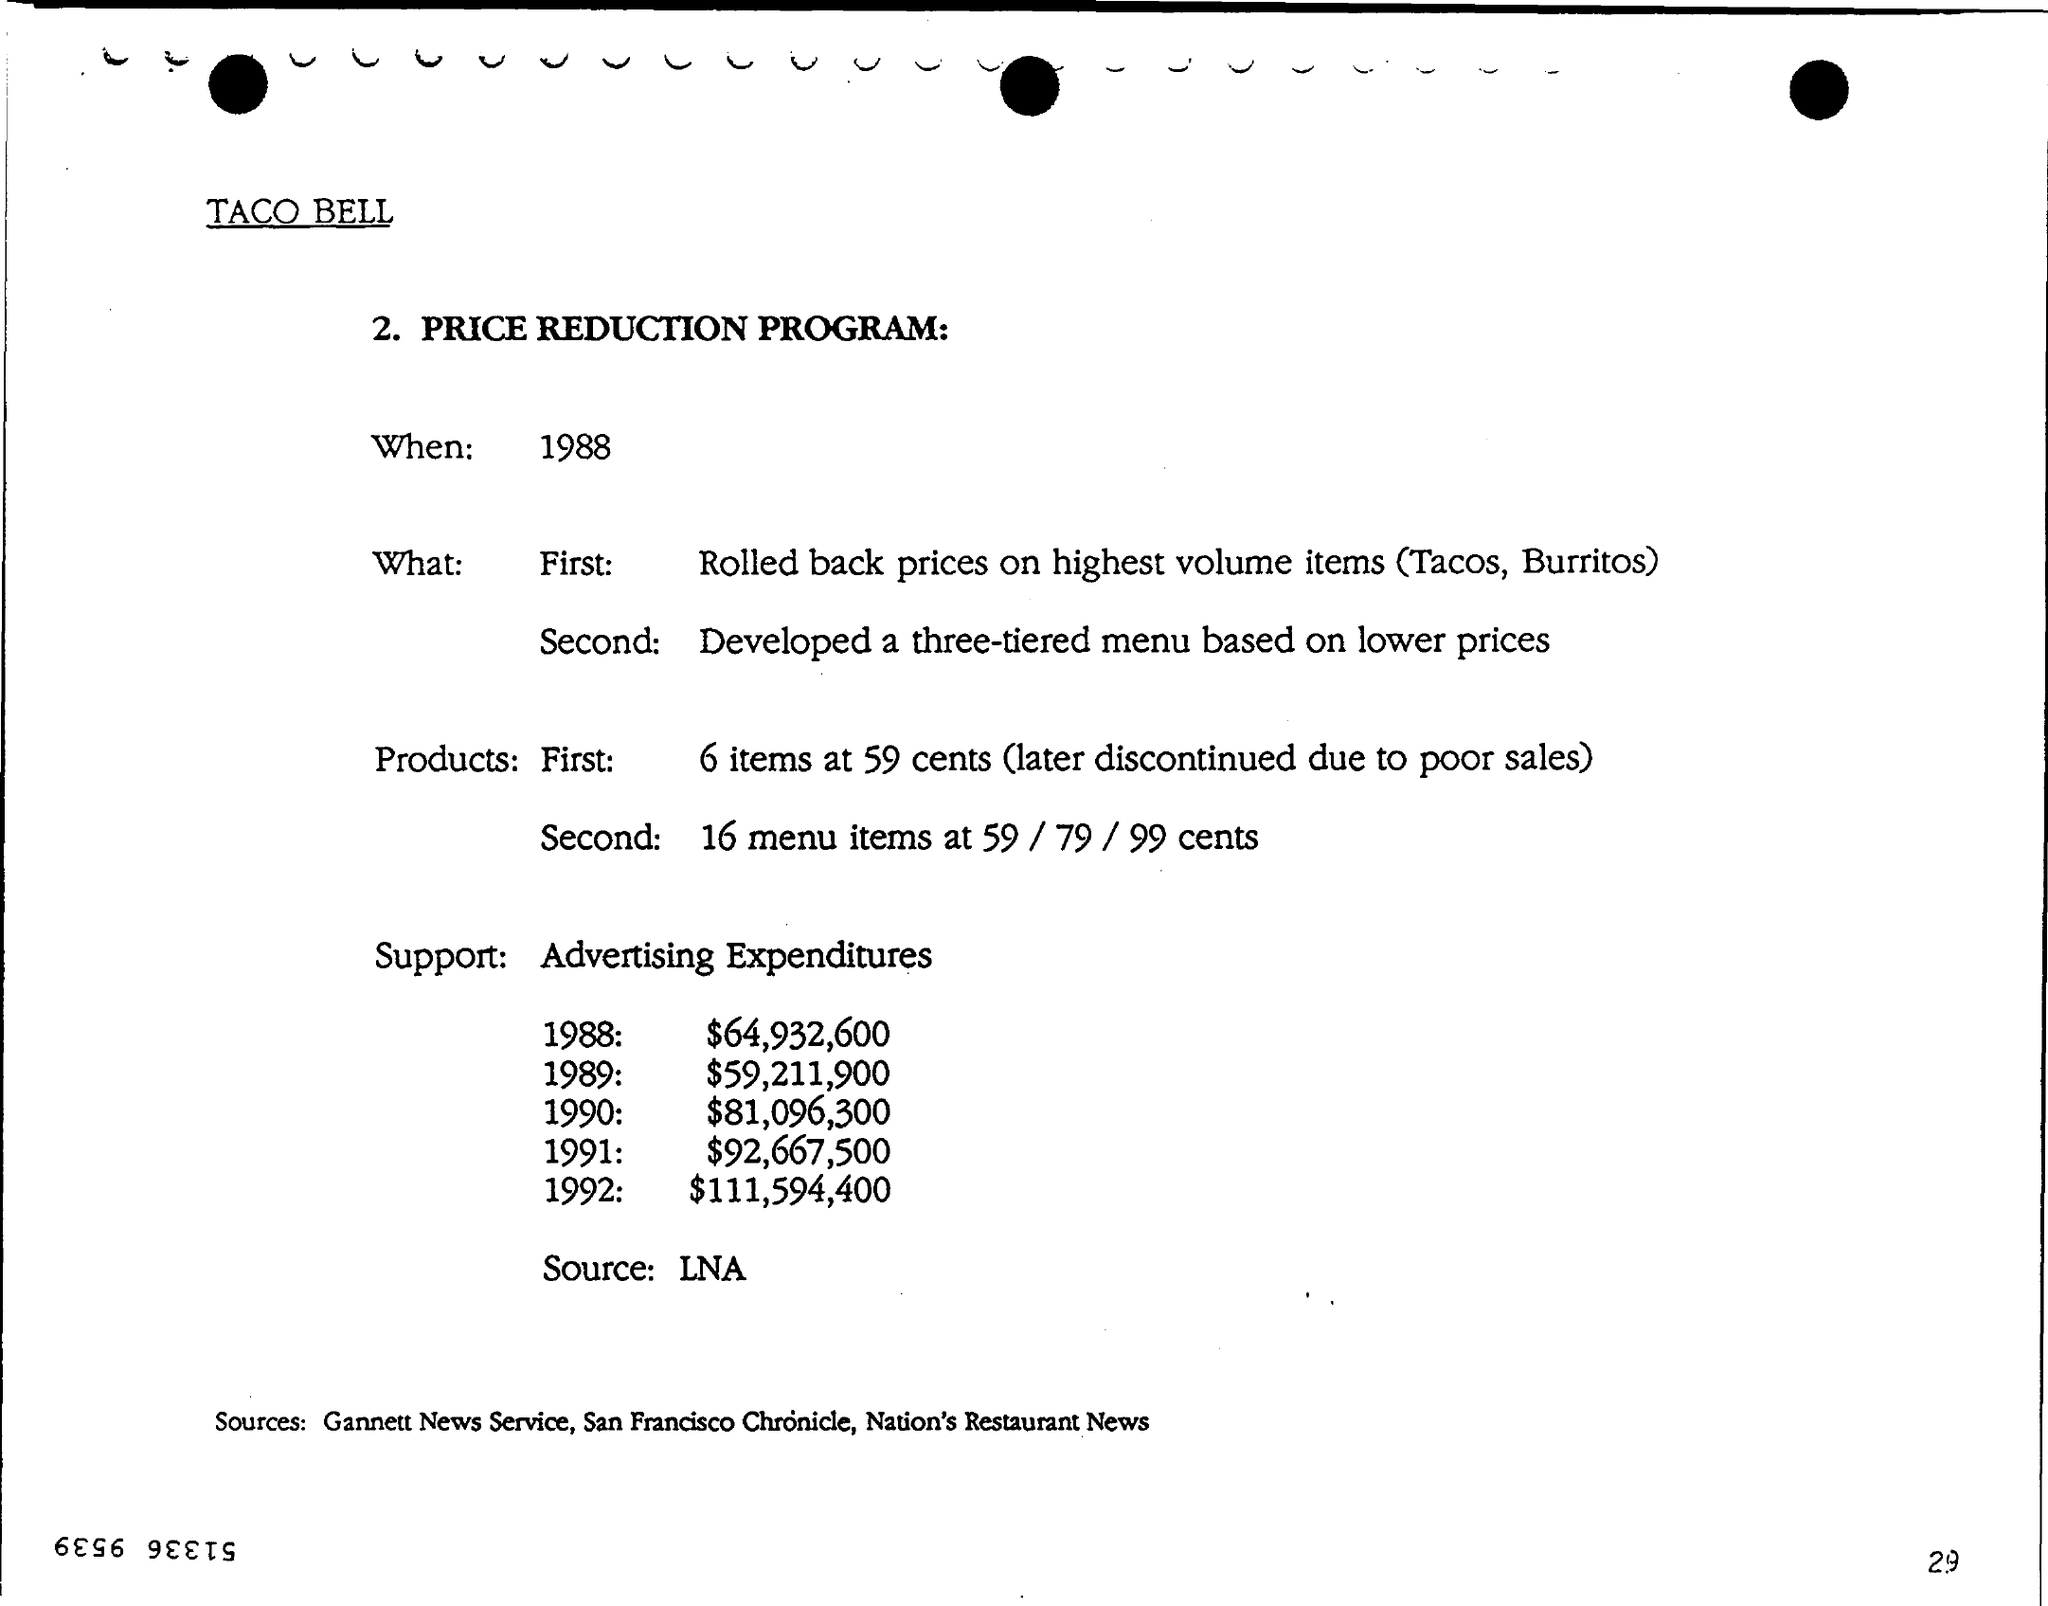Can you give a summary of the Taco Bell Price Reduction Program mentioned in this image? Certainly! In 1988, Taco Bell implemented a Price Reduction Program where it initially reduced prices on high-volume items such as Tacos and Burritos. Furthermore, they introduced a tiered menu with lower prices, featuring six items at 59 cents initially, which was later discontinued due to poor sales, and 16 items ranging from 59 to 99 cents. The program was supported by significant advertising expenditures that increased annually from 1988 through 1992. 